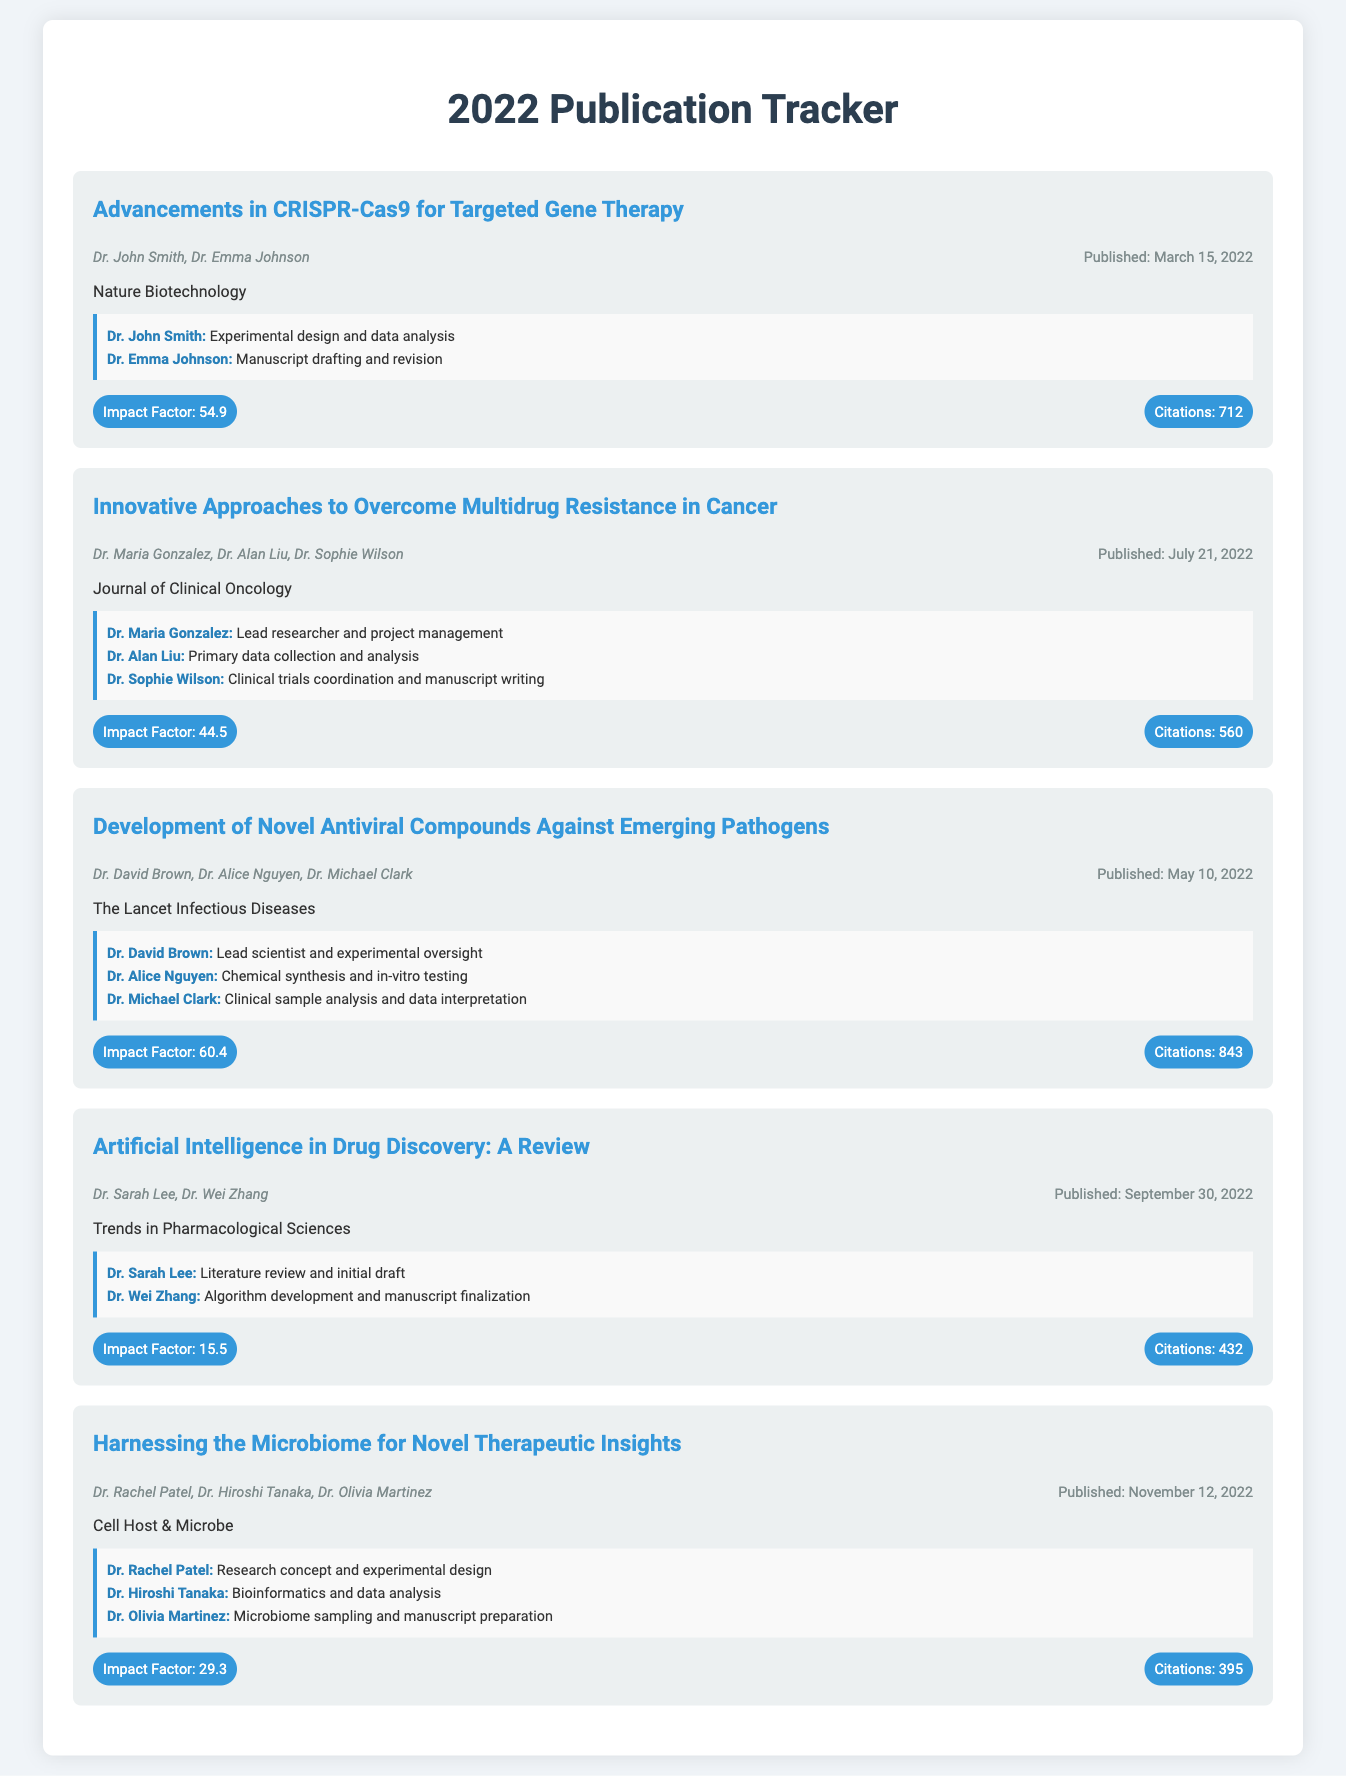What is the title of the first publication? The title of the first publication is found at the beginning section of the first publication entry.
Answer: Advancements in CRISPR-Cas9 for Targeted Gene Therapy Who are the authors of the publication published in July 2022? The authors of the July 2022 publication are mentioned in the publication-info section of that entry.
Answer: Dr. Maria Gonzalez, Dr. Alan Liu, Dr. Sophie Wilson What is the impact factor of the journal "The Lancet Infectious Diseases"? The impact factor for "The Lancet Infectious Diseases" is listed in the stats section of its publication entry.
Answer: 60.4 How many citations did the publication on artificial intelligence receive? The citation count for the publication on artificial intelligence can be found in the stats section of that entry.
Answer: 432 Which publication has the highest number of citations? A comparison of the citation counts is required to determine the publication with the highest number of citations.
Answer: Development of Novel Antiviral Compounds Against Emerging Pathogens What contribution did Dr. Emma Johnson make in her publication? The specific contributions of authors are detailed in the contribution sections of each publication.
Answer: Manuscript drafting and revision Which journal has the lowest impact factor among the listed publications? This requires comparing the impact factors of each journal in the stats section.
Answer: Trends in Pharmacological Sciences What date was "Harnessing the Microbiome for Novel Therapeutic Insights" published? The publication date is noted in the publication-info section of that entry.
Answer: November 12, 2022 